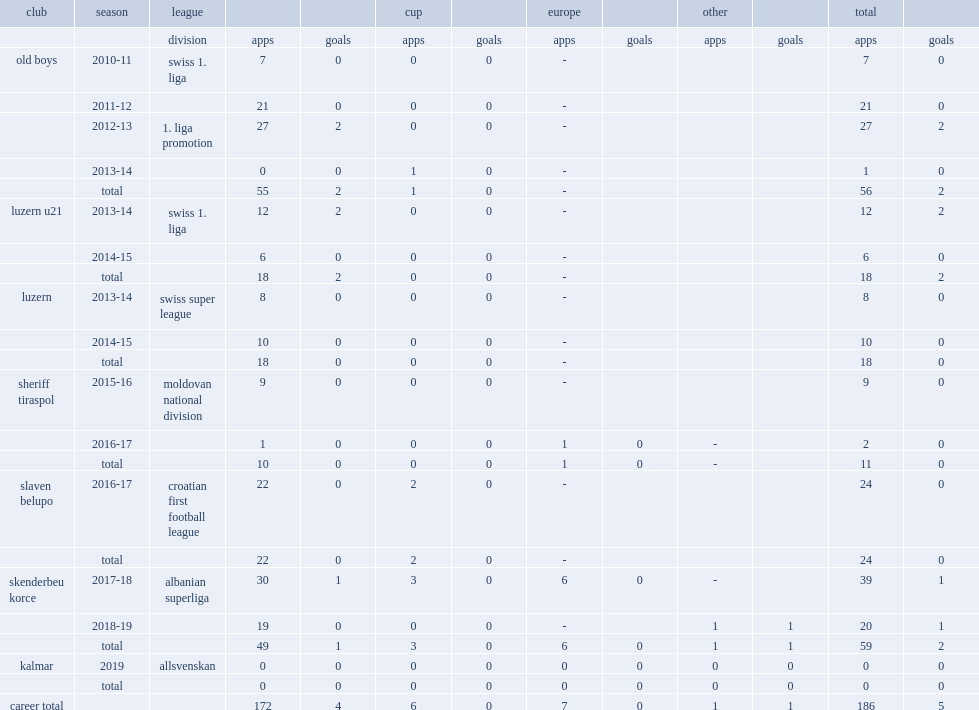In 2019, which league did aliti join side kalmar? Allsvenskan. 